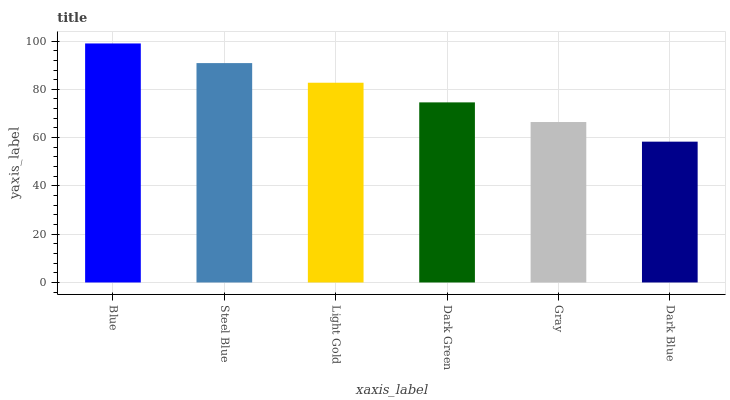Is Dark Blue the minimum?
Answer yes or no. Yes. Is Blue the maximum?
Answer yes or no. Yes. Is Steel Blue the minimum?
Answer yes or no. No. Is Steel Blue the maximum?
Answer yes or no. No. Is Blue greater than Steel Blue?
Answer yes or no. Yes. Is Steel Blue less than Blue?
Answer yes or no. Yes. Is Steel Blue greater than Blue?
Answer yes or no. No. Is Blue less than Steel Blue?
Answer yes or no. No. Is Light Gold the high median?
Answer yes or no. Yes. Is Dark Green the low median?
Answer yes or no. Yes. Is Dark Green the high median?
Answer yes or no. No. Is Gray the low median?
Answer yes or no. No. 